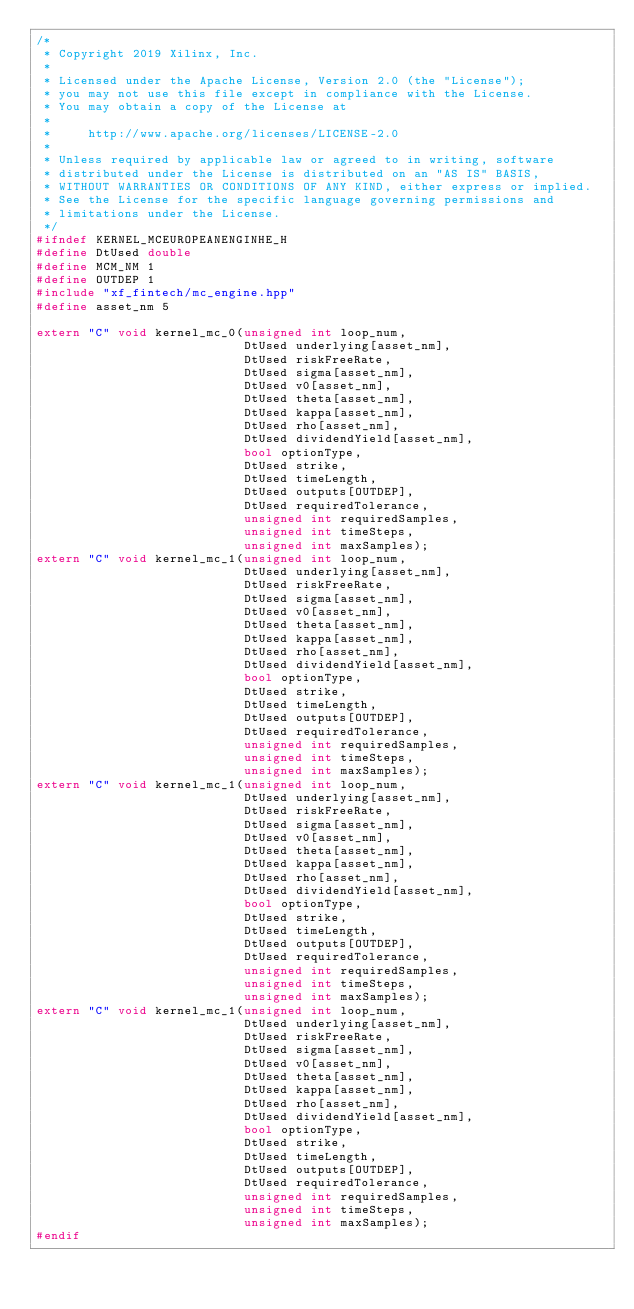Convert code to text. <code><loc_0><loc_0><loc_500><loc_500><_C++_>/*
 * Copyright 2019 Xilinx, Inc.
 *
 * Licensed under the Apache License, Version 2.0 (the "License");
 * you may not use this file except in compliance with the License.
 * You may obtain a copy of the License at
 *
 *     http://www.apache.org/licenses/LICENSE-2.0
 *
 * Unless required by applicable law or agreed to in writing, software
 * distributed under the License is distributed on an "AS IS" BASIS,
 * WITHOUT WARRANTIES OR CONDITIONS OF ANY KIND, either express or implied.
 * See the License for the specific language governing permissions and
 * limitations under the License.
 */
#ifndef KERNEL_MCEUROPEANENGINHE_H
#define DtUsed double
#define MCM_NM 1
#define OUTDEP 1
#include "xf_fintech/mc_engine.hpp"
#define asset_nm 5

extern "C" void kernel_mc_0(unsigned int loop_num,
                            DtUsed underlying[asset_nm],
                            DtUsed riskFreeRate,
                            DtUsed sigma[asset_nm],
                            DtUsed v0[asset_nm],
                            DtUsed theta[asset_nm],
                            DtUsed kappa[asset_nm],
                            DtUsed rho[asset_nm],
                            DtUsed dividendYield[asset_nm],
                            bool optionType,
                            DtUsed strike,
                            DtUsed timeLength,
                            DtUsed outputs[OUTDEP],
                            DtUsed requiredTolerance,
                            unsigned int requiredSamples,
                            unsigned int timeSteps,
                            unsigned int maxSamples);
extern "C" void kernel_mc_1(unsigned int loop_num,
                            DtUsed underlying[asset_nm],
                            DtUsed riskFreeRate,
                            DtUsed sigma[asset_nm],
                            DtUsed v0[asset_nm],
                            DtUsed theta[asset_nm],
                            DtUsed kappa[asset_nm],
                            DtUsed rho[asset_nm],
                            DtUsed dividendYield[asset_nm],
                            bool optionType,
                            DtUsed strike,
                            DtUsed timeLength,
                            DtUsed outputs[OUTDEP],
                            DtUsed requiredTolerance,
                            unsigned int requiredSamples,
                            unsigned int timeSteps,
                            unsigned int maxSamples);
extern "C" void kernel_mc_1(unsigned int loop_num,
                            DtUsed underlying[asset_nm],
                            DtUsed riskFreeRate,
                            DtUsed sigma[asset_nm],
                            DtUsed v0[asset_nm],
                            DtUsed theta[asset_nm],
                            DtUsed kappa[asset_nm],
                            DtUsed rho[asset_nm],
                            DtUsed dividendYield[asset_nm],
                            bool optionType,
                            DtUsed strike,
                            DtUsed timeLength,
                            DtUsed outputs[OUTDEP],
                            DtUsed requiredTolerance,
                            unsigned int requiredSamples,
                            unsigned int timeSteps,
                            unsigned int maxSamples);
extern "C" void kernel_mc_1(unsigned int loop_num,
                            DtUsed underlying[asset_nm],
                            DtUsed riskFreeRate,
                            DtUsed sigma[asset_nm],
                            DtUsed v0[asset_nm],
                            DtUsed theta[asset_nm],
                            DtUsed kappa[asset_nm],
                            DtUsed rho[asset_nm],
                            DtUsed dividendYield[asset_nm],
                            bool optionType,
                            DtUsed strike,
                            DtUsed timeLength,
                            DtUsed outputs[OUTDEP],
                            DtUsed requiredTolerance,
                            unsigned int requiredSamples,
                            unsigned int timeSteps,
                            unsigned int maxSamples);
#endif
</code> 